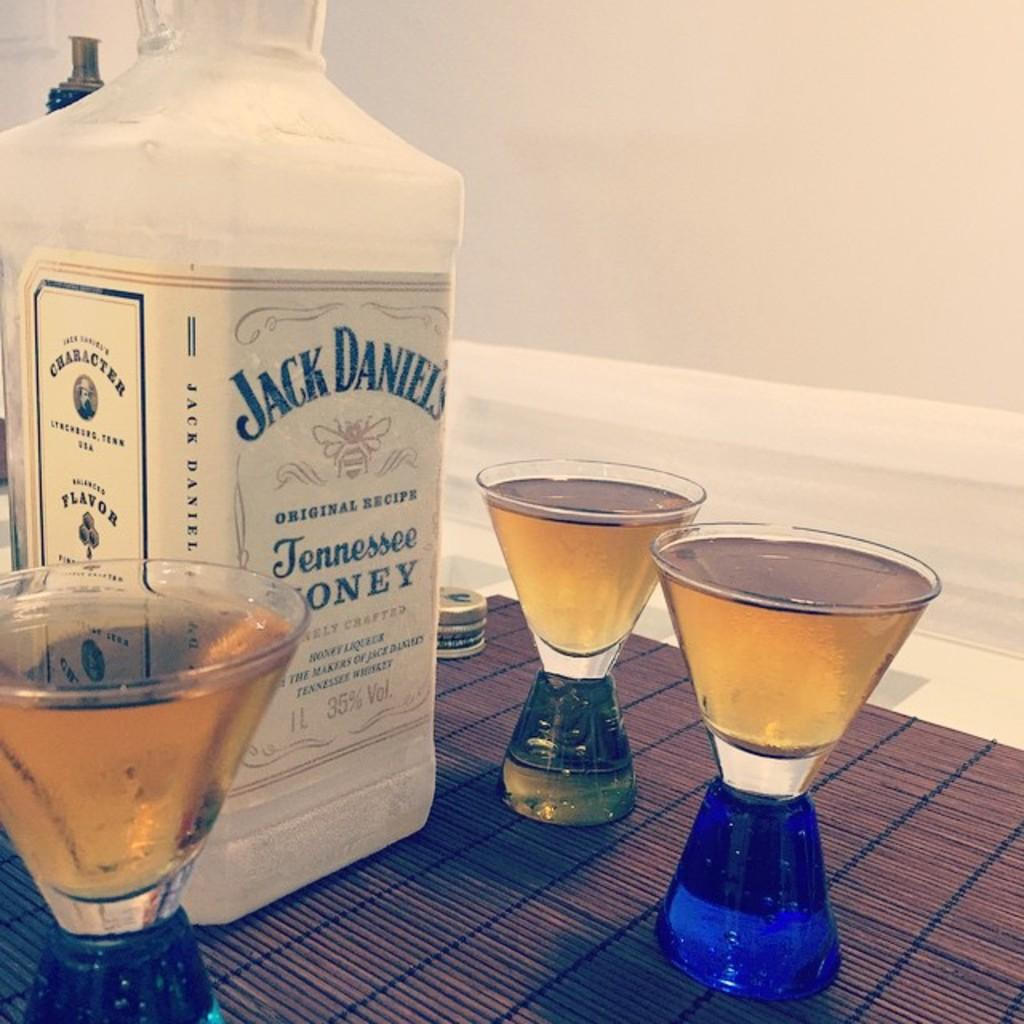<image>
Share a concise interpretation of the image provided. three shot glasses filled with some jack daniel's tennessee honey whiskey 